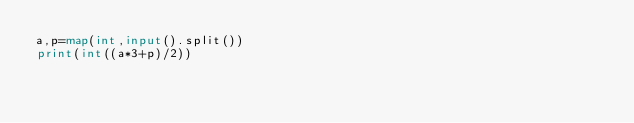Convert code to text. <code><loc_0><loc_0><loc_500><loc_500><_Python_>a,p=map(int,input().split())
print(int((a*3+p)/2))
</code> 